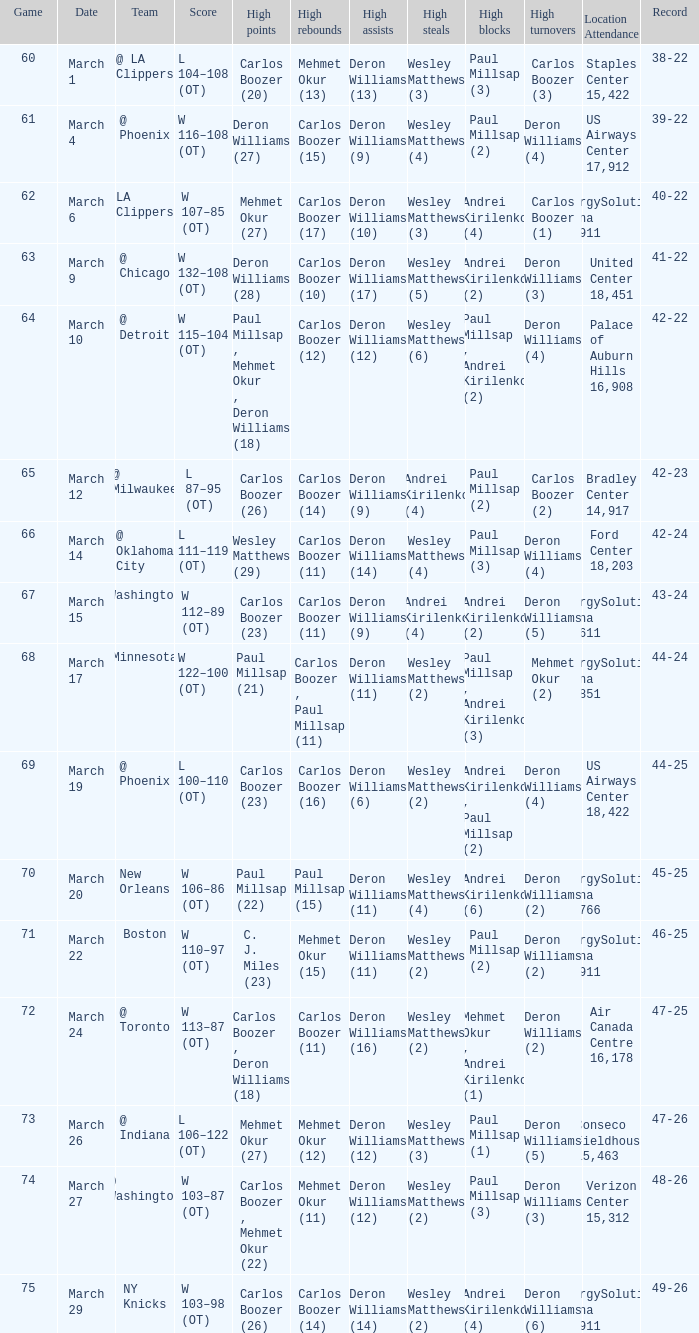How many players did the most high points in the game with 39-22 record? 1.0. 